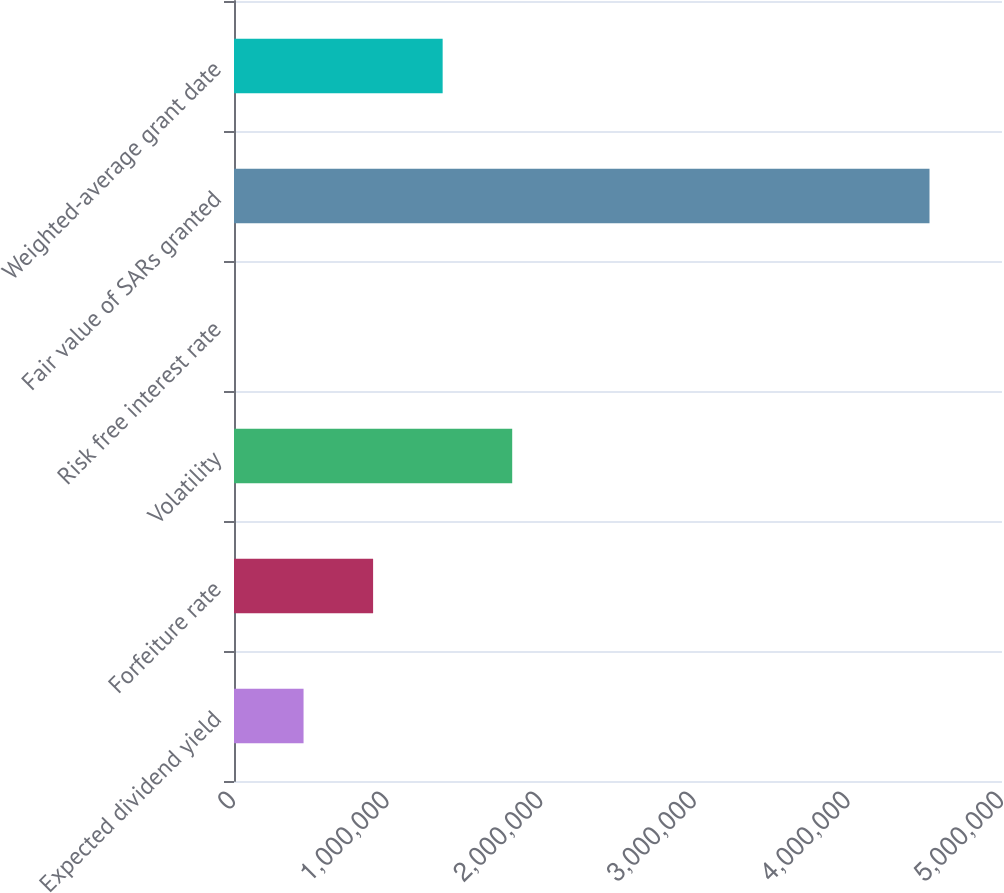Convert chart. <chart><loc_0><loc_0><loc_500><loc_500><bar_chart><fcel>Expected dividend yield<fcel>Forfeiture rate<fcel>Volatility<fcel>Risk free interest rate<fcel>Fair value of SARs granted<fcel>Weighted-average grant date<nl><fcel>452801<fcel>905601<fcel>1.8112e+06<fcel>0.82<fcel>4.528e+06<fcel>1.3584e+06<nl></chart> 